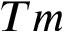Convert formula to latex. <formula><loc_0><loc_0><loc_500><loc_500>T m</formula> 